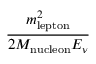<formula> <loc_0><loc_0><loc_500><loc_500>\frac { m _ { l e p t o n } ^ { 2 } } { 2 M _ { n u c l e o n } E _ { \nu } }</formula> 